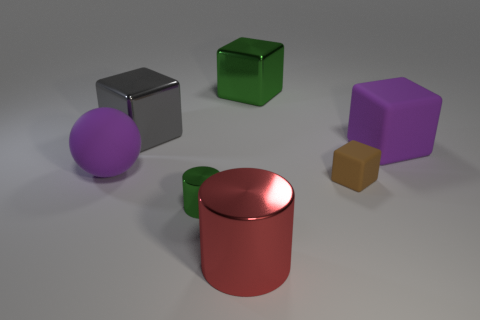Is there another tiny green metallic object that has the same shape as the tiny green object?
Keep it short and to the point. No. What is the shape of the other shiny object that is the same size as the brown object?
Your answer should be very brief. Cylinder. What number of things are either purple objects that are left of the large gray block or big shiny cubes?
Keep it short and to the point. 3. Is the color of the big ball the same as the tiny cube?
Provide a short and direct response. No. What is the size of the matte object behind the big rubber ball?
Make the answer very short. Large. Is there a cyan rubber object of the same size as the gray object?
Keep it short and to the point. No. There is a green metal thing that is behind the purple matte sphere; does it have the same size as the large red thing?
Make the answer very short. Yes. What is the size of the green shiny block?
Your response must be concise. Large. What color is the large matte object that is in front of the large purple thing to the right of the block that is on the left side of the big green cube?
Make the answer very short. Purple. There is a big thing on the right side of the tiny brown object; is it the same color as the tiny block?
Your response must be concise. No. 